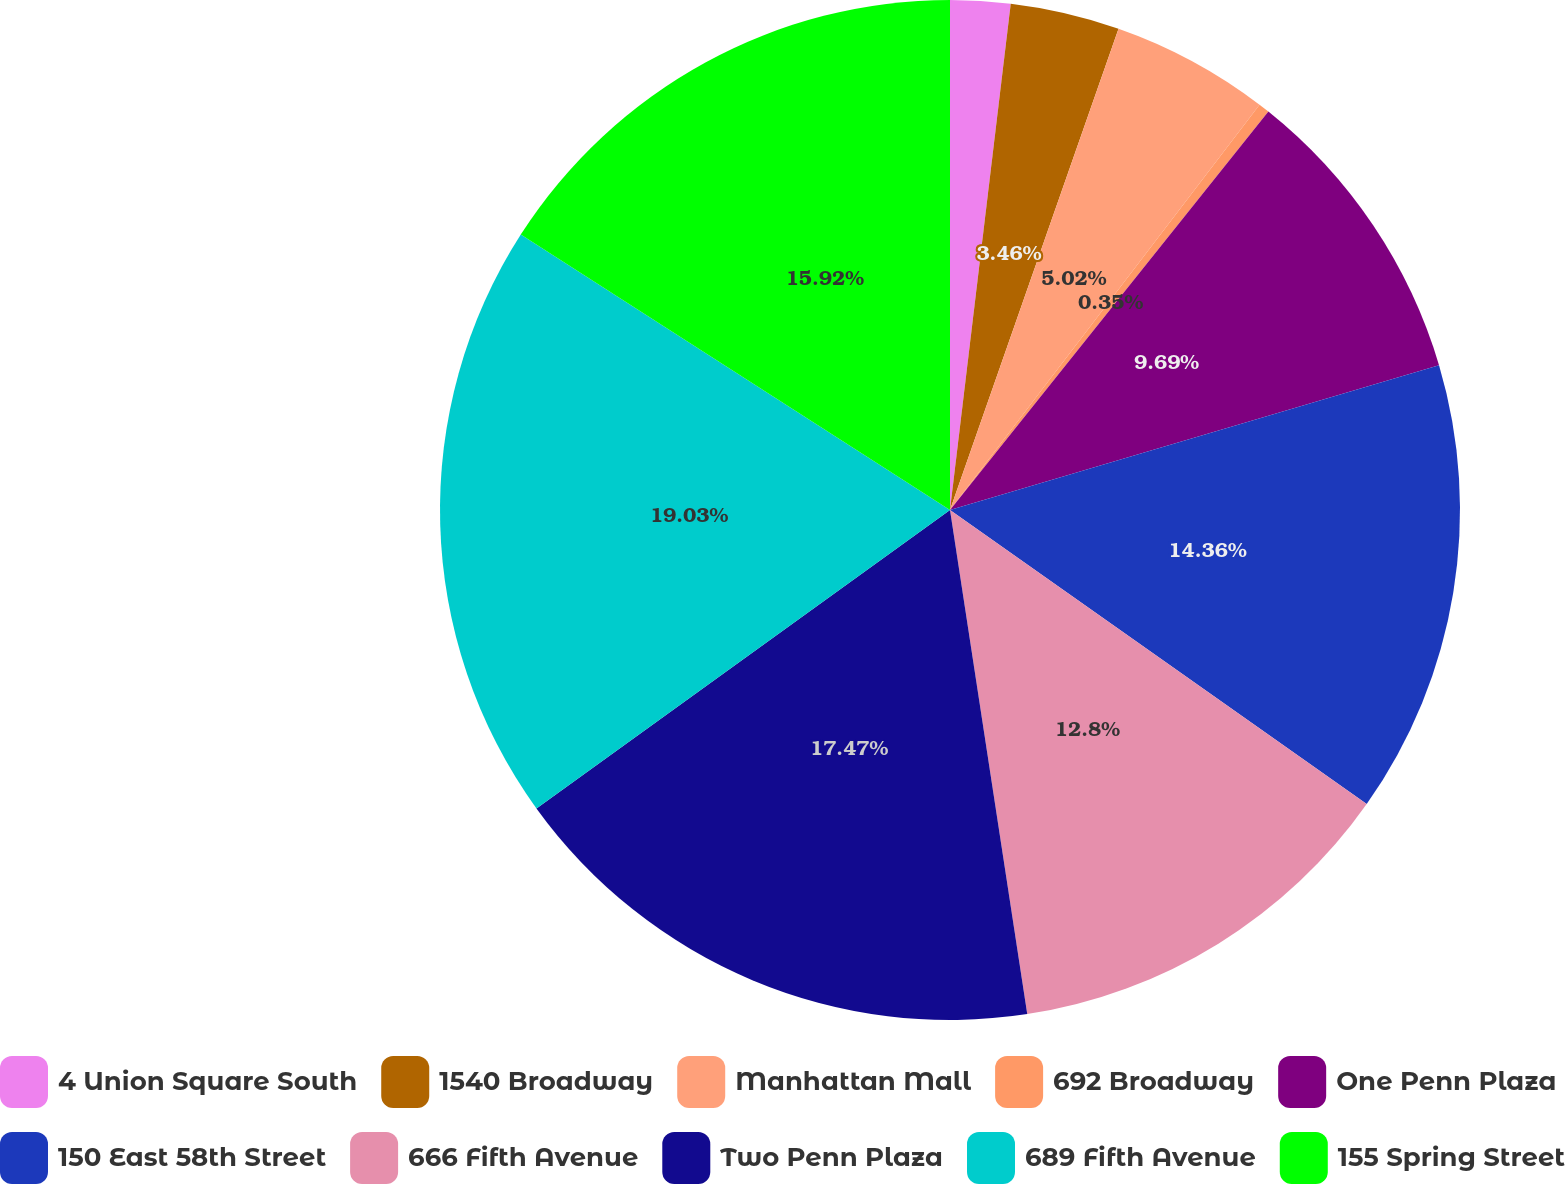Convert chart to OTSL. <chart><loc_0><loc_0><loc_500><loc_500><pie_chart><fcel>4 Union Square South<fcel>1540 Broadway<fcel>Manhattan Mall<fcel>692 Broadway<fcel>One Penn Plaza<fcel>150 East 58th Street<fcel>666 Fifth Avenue<fcel>Two Penn Plaza<fcel>689 Fifth Avenue<fcel>155 Spring Street<nl><fcel>1.9%<fcel>3.46%<fcel>5.02%<fcel>0.35%<fcel>9.69%<fcel>14.36%<fcel>12.8%<fcel>17.47%<fcel>19.03%<fcel>15.92%<nl></chart> 